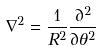<formula> <loc_0><loc_0><loc_500><loc_500>\nabla ^ { 2 } = \frac { 1 } { R ^ { 2 } } \frac { \partial ^ { 2 } } { \partial \theta ^ { 2 } }</formula> 